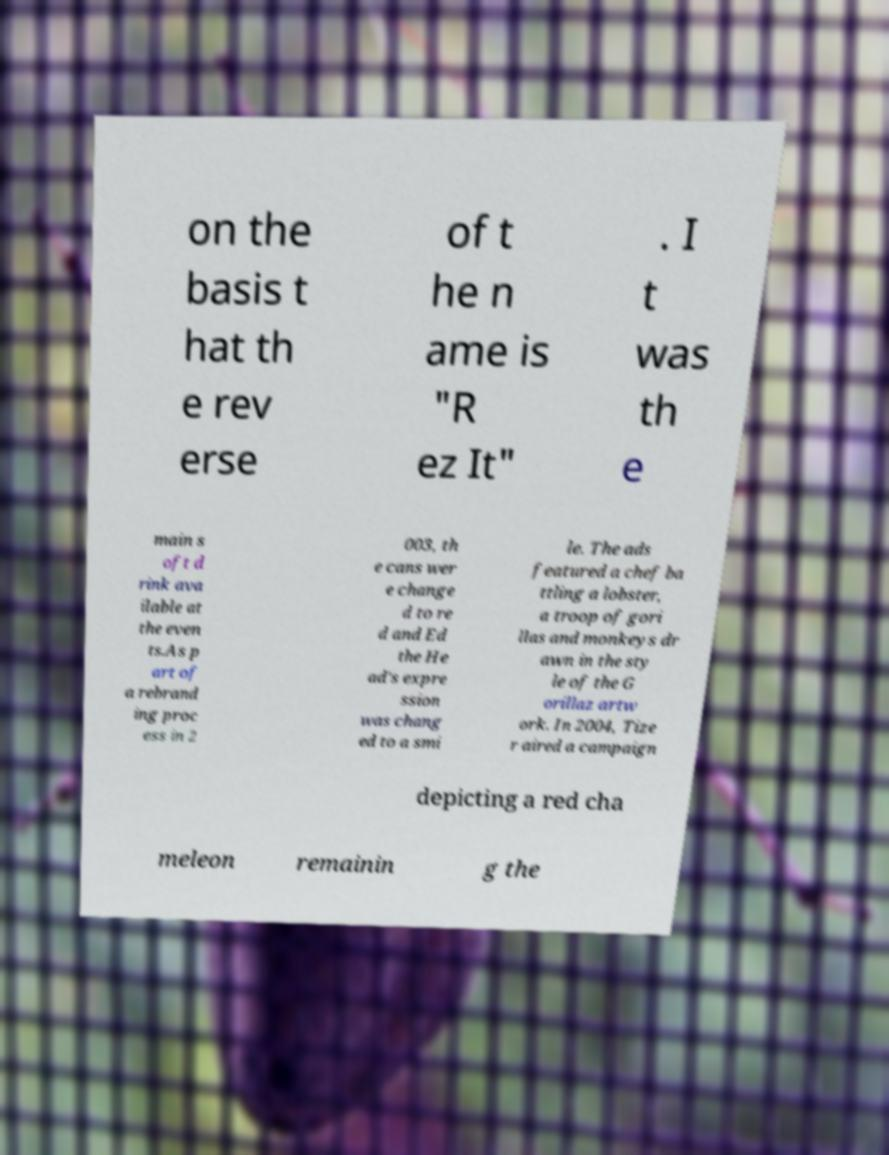Can you read and provide the text displayed in the image?This photo seems to have some interesting text. Can you extract and type it out for me? on the basis t hat th e rev erse of t he n ame is "R ez It" . I t was th e main s oft d rink ava ilable at the even ts.As p art of a rebrand ing proc ess in 2 003, th e cans wer e change d to re d and Ed the He ad's expre ssion was chang ed to a smi le. The ads featured a chef ba ttling a lobster, a troop of gori llas and monkeys dr awn in the sty le of the G orillaz artw ork. In 2004, Tize r aired a campaign depicting a red cha meleon remainin g the 